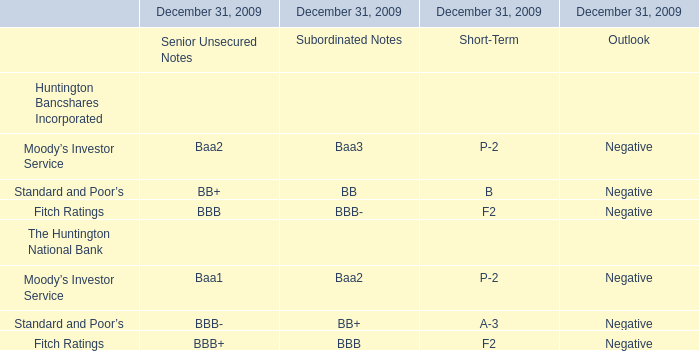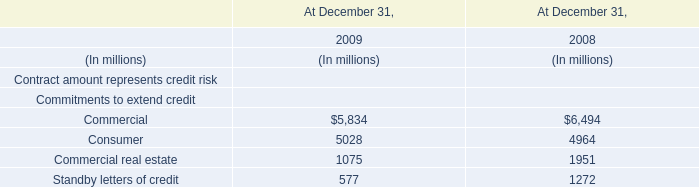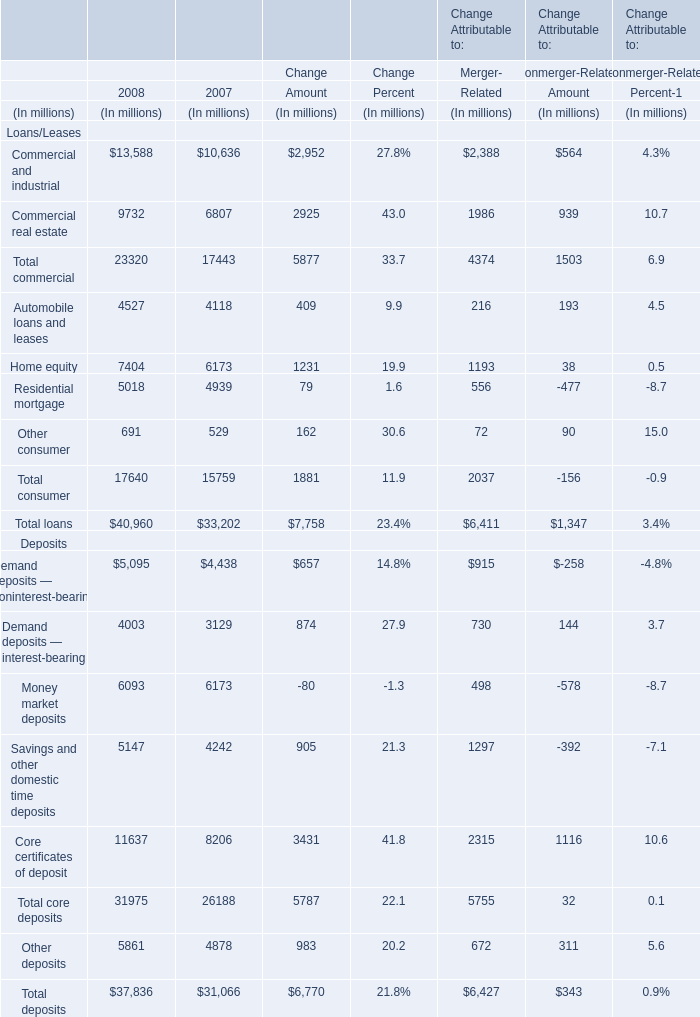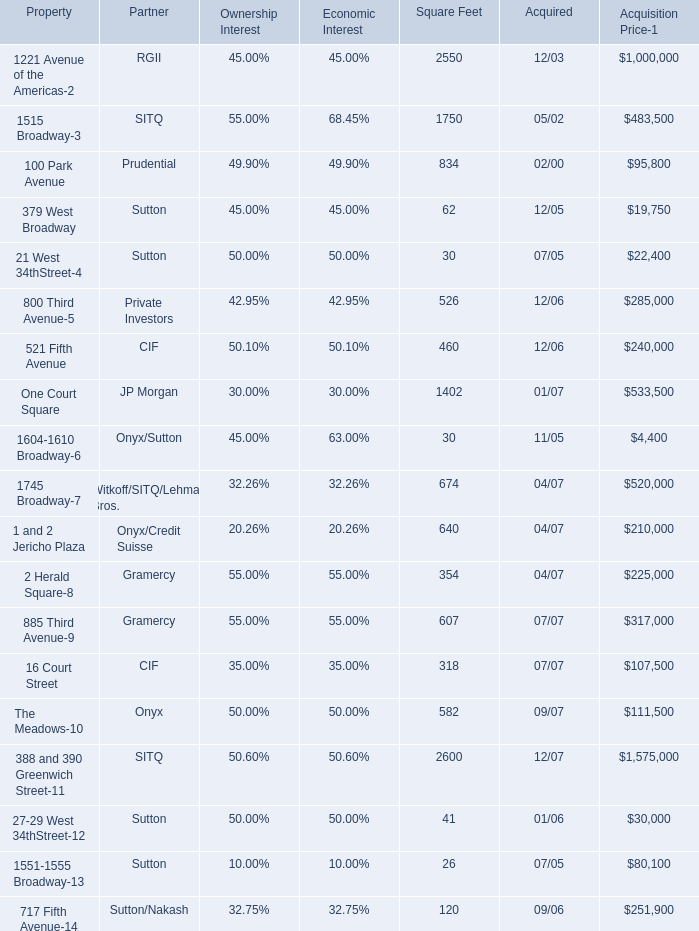In what year is Home equity greater than 7000? 
Answer: 2008. 